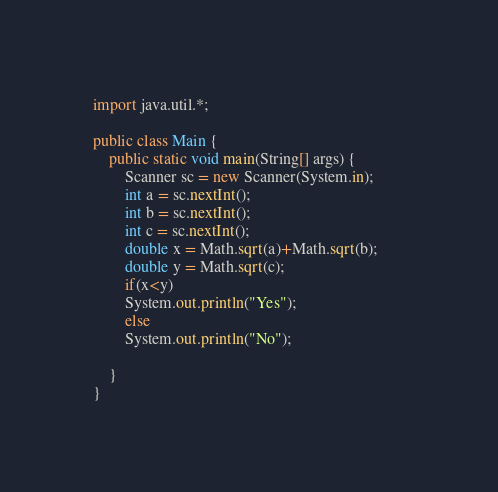<code> <loc_0><loc_0><loc_500><loc_500><_Java_>import java.util.*;

public class Main {
	public static void main(String[] args) {
		Scanner sc = new Scanner(System.in);		
		int a = sc.nextInt();		
		int b = sc.nextInt();
		int c = sc.nextInt();
		double x = Math.sqrt(a)+Math.sqrt(b);
		double y = Math.sqrt(c);
		if(x<y)
		System.out.println("Yes");
	    else
		System.out.println("No");
	    
	}	
}
</code> 